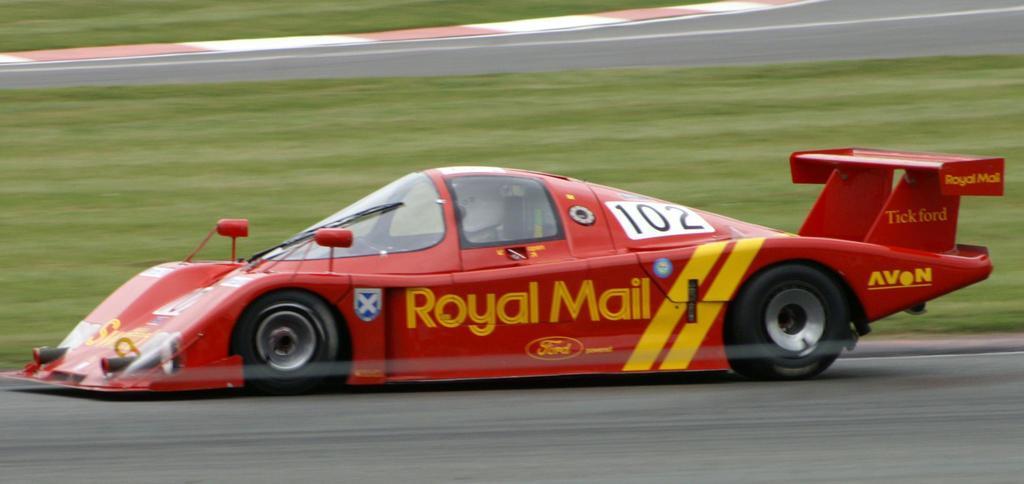Could you give a brief overview of what you see in this image? In this image there is a racing car on the track, on the other side of the car there's grass on the surface. 